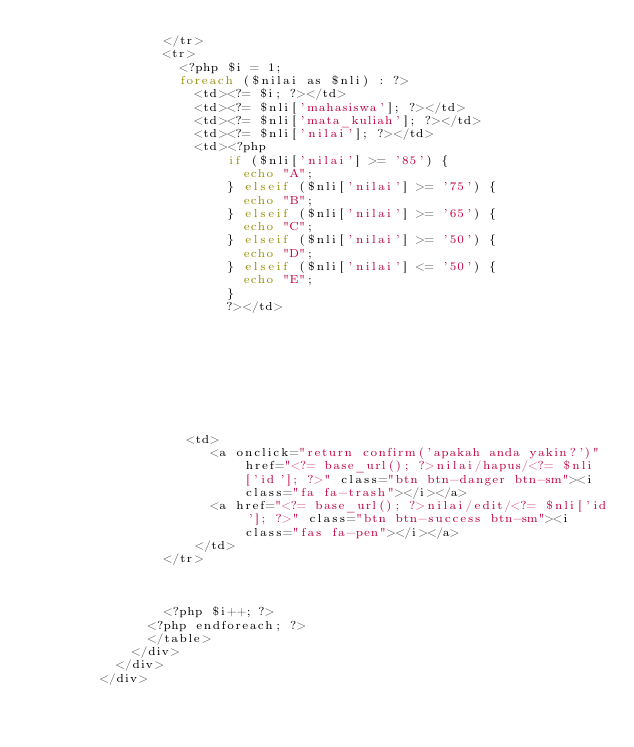Convert code to text. <code><loc_0><loc_0><loc_500><loc_500><_PHP_>                </tr>
                <tr>
                  <?php $i = 1;
                  foreach ($nilai as $nli) : ?>
                    <td><?= $i; ?></td>
                    <td><?= $nli['mahasiswa']; ?></td>
                    <td><?= $nli['mata_kuliah']; ?></td>
                    <td><?= $nli['nilai']; ?></td>
                    <td><?php
                        if ($nli['nilai'] >= '85') {
                          echo "A";
                        } elseif ($nli['nilai'] >= '75') {
                          echo "B";
                        } elseif ($nli['nilai'] >= '65') {
                          echo "C";
                        } elseif ($nli['nilai'] >= '50') {
                          echo "D";
                        } elseif ($nli['nilai'] <= '50') {
                          echo "E";
                        }
                        ?></td>
                   
                   
                   
    
                   
                   
                   
                   
                   
                   <td>
                      <a onclick="return confirm('apakah anda yakin?')" href="<?= base_url(); ?>nilai/hapus/<?= $nli['id']; ?>" class="btn btn-danger btn-sm"><i class="fa fa-trash"></i></a>
                      <a href="<?= base_url(); ?>nilai/edit/<?= $nli['id']; ?>" class="btn btn-success btn-sm"><i class="fas fa-pen"></i></a>
                    </td>
                </tr>



                <?php $i++; ?>
              <?php endforeach; ?>
              </table>
            </div>
          </div>
        </div></code> 